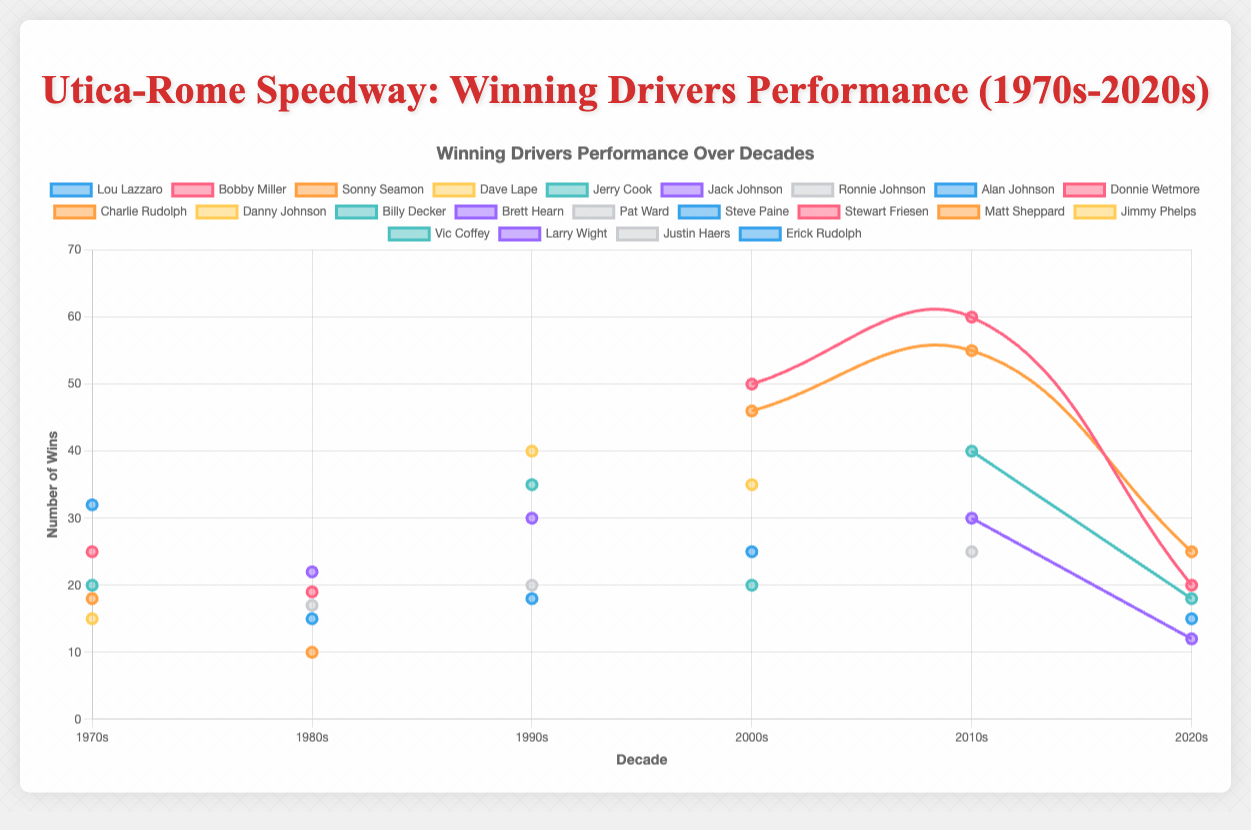What decade did Stewart Friesen achieve the most wins? Look at Stewart Friesen's plot and find the decade with the highest point. It's the 2010s with 60 wins.
Answer: 2010s Did Matt Sheppard or Lou Lazzaro have more wins in their highest winning decade? Compare the highest points for Matt Sheppard and Lou Lazzaro in their respective plots. Matt Sheppard has 55 wins in the 2010s, while Lou Lazzaro has 32 wins in the 1970s.
Answer: Matt Sheppard How do the wins of Billy Decker in the 2010s compare to his wins in the 1990s? Find Billy Decker's points in the 1990s and 2010s on the chart. In the 1990s, he had 35 wins, and in the 2010s, he had 40 wins.
Answer: 40 wins in 2010s, 35 wins in 1990s What is the trend of Alan Johnson's wins from the 1980s to the 2000s? Locate Alan Johnson's line and follow its progression from the 1980s to the 2000s. He has 15 wins in the 1980s and 25 wins in the 2000s. The trend shows an increase over these decades.
Answer: Increasing Who had a higher number of wins in the 2000s, Jimmy Phelps or Alan Johnson? Compare the points for Jimmy Phelps and Alan Johnson in the 2000s. Jimmy Phelps has 35 wins, while Alan Johnson has 25 wins.
Answer: Jimmy Phelps Calculate the average number of wins for the top driver in each decade. Sum the highest win counts for each decade (32 + 22 + 40 + 50 + 60 + 25) = 229, then divide by the number of decades (6).
Answer: 38.2 Which driver had the greatest decline in wins from one decade to the next? Compare the changes in wins for each driver across consecutive decades. Stewart Friesen goes from 60 wins in the 2010s to 20 wins in the 2020s, which is a decline of 40 wins.
Answer: Stewart Friesen Between the 1990s and the 2010s, which driver showed the most consistent performance in terms of wins? Determine which driver had the least variation in wins between these two decades. Billy Decker shows 35 wins in the 1990s and 40 wins in the 2010s, having a difference of 5 wins.
Answer: Billy Decker 